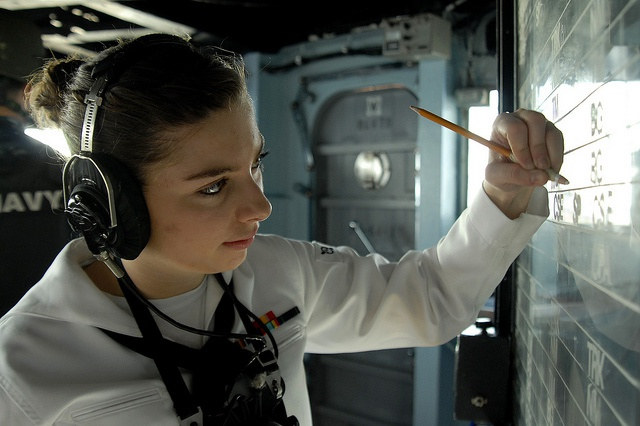Describe the objects in this image and their specific colors. I can see people in darkgray, black, gray, and maroon tones and tie in darkgray and black tones in this image. 